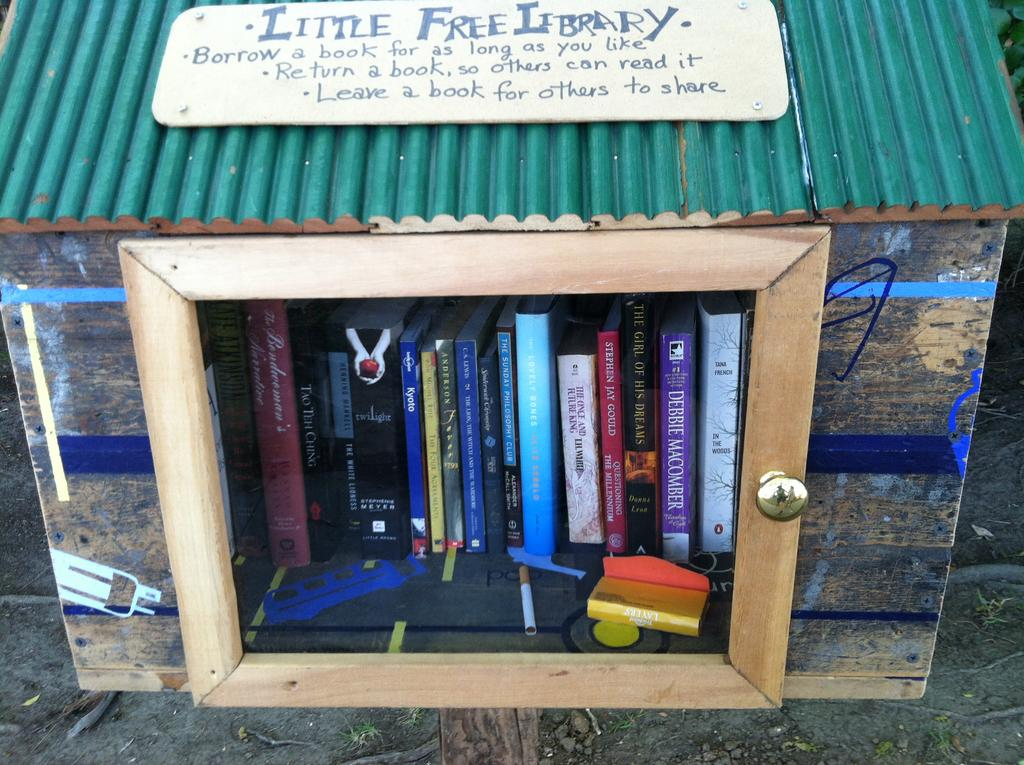<image>
Summarize the visual content of the image. A little free library includes a book by Stephen Jay Gould. 